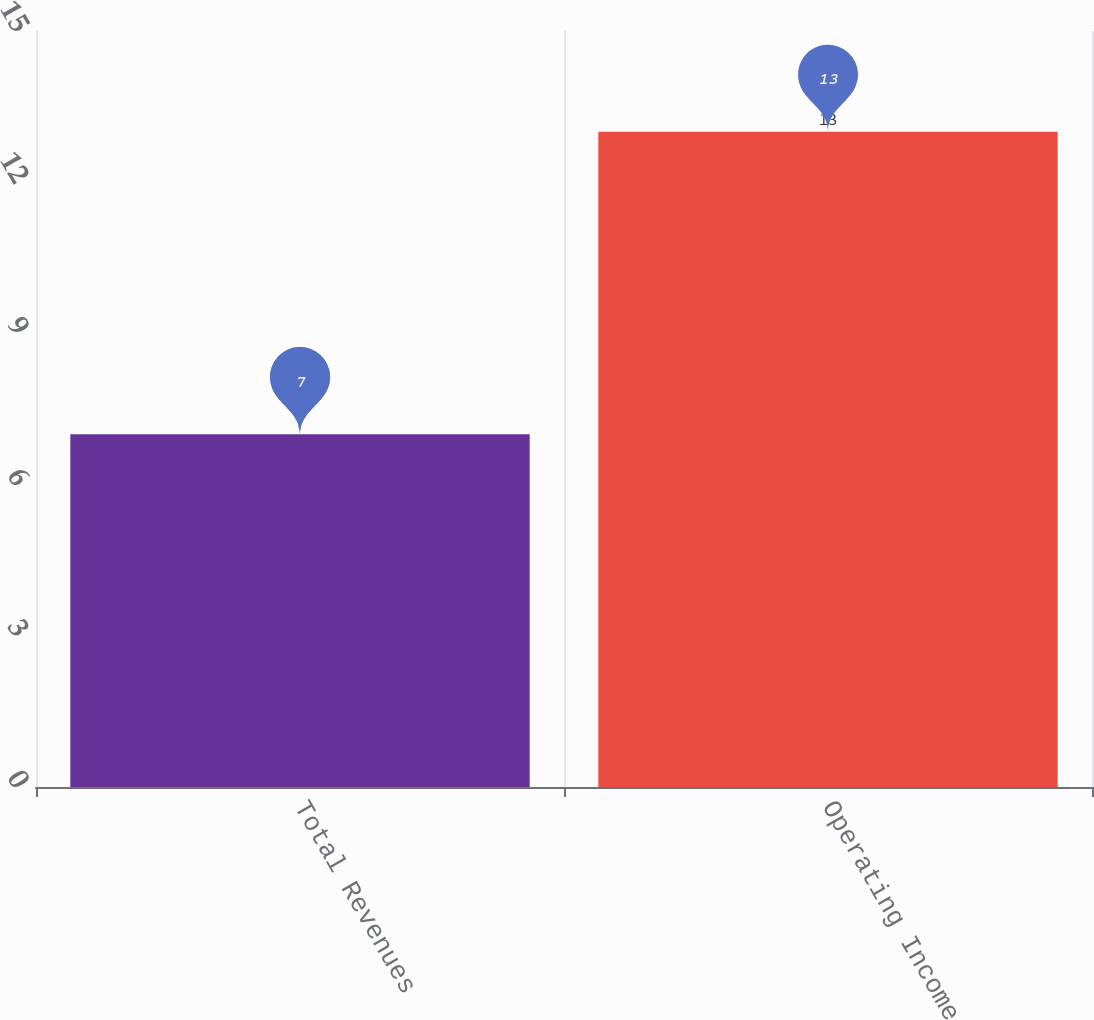<chart> <loc_0><loc_0><loc_500><loc_500><bar_chart><fcel>Total Revenues<fcel>Operating Income<nl><fcel>7<fcel>13<nl></chart> 